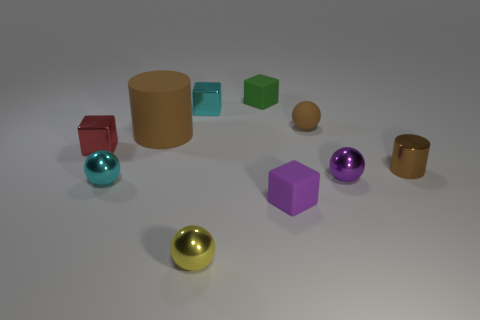Subtract all blocks. How many objects are left? 6 Add 3 brown matte cylinders. How many brown matte cylinders exist? 4 Subtract 0 red cylinders. How many objects are left? 10 Subtract all large purple balls. Subtract all green rubber cubes. How many objects are left? 9 Add 2 small brown rubber objects. How many small brown rubber objects are left? 3 